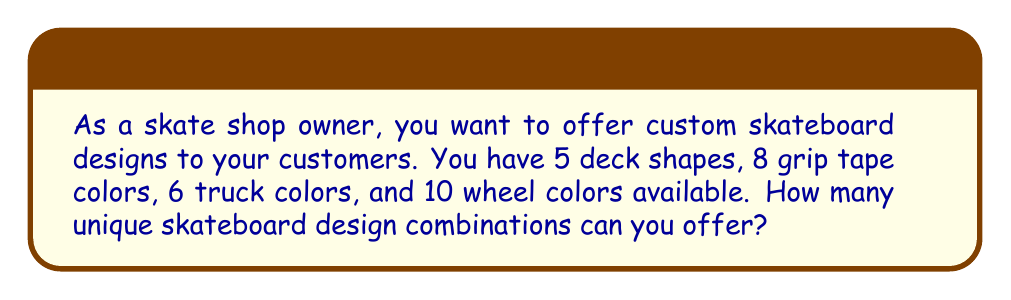Provide a solution to this math problem. Let's break this down step-by-step:

1. We have four independent components that can be chosen:
   - Deck shape
   - Grip tape color
   - Truck color
   - Wheel color

2. For each component, we have a certain number of choices:
   - 5 deck shapes
   - 8 grip tape colors
   - 6 truck colors
   - 10 wheel colors

3. According to the multiplication principle in combinatorics, when we have independent choices, we multiply the number of options for each choice to get the total number of combinations.

4. Therefore, the total number of unique skateboard design combinations is:

   $$ 5 \times 8 \times 6 \times 10 $$

5. Let's calculate this:
   $$ 5 \times 8 \times 6 \times 10 = 2400 $$

Thus, you can offer 2400 unique skateboard design combinations to your customers.
Answer: 2400 